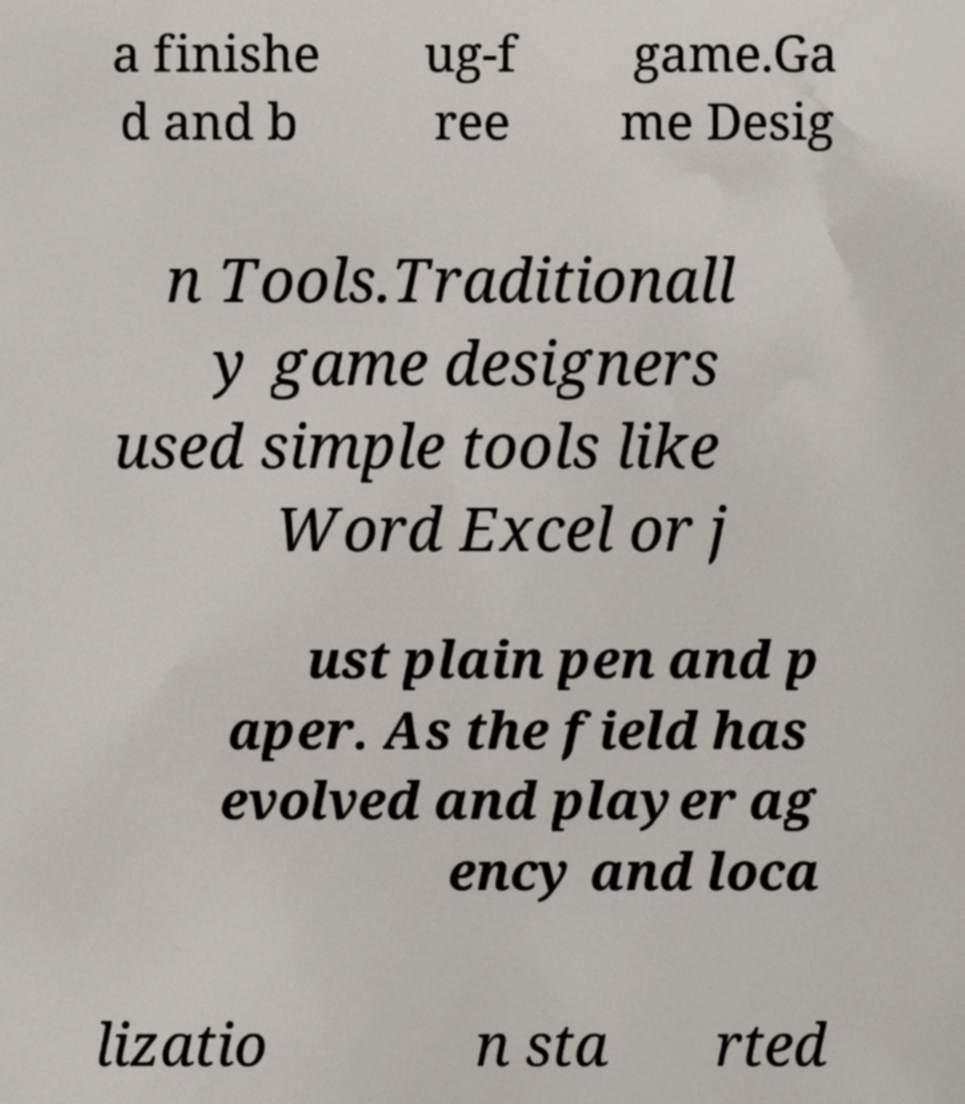Can you accurately transcribe the text from the provided image for me? a finishe d and b ug-f ree game.Ga me Desig n Tools.Traditionall y game designers used simple tools like Word Excel or j ust plain pen and p aper. As the field has evolved and player ag ency and loca lizatio n sta rted 